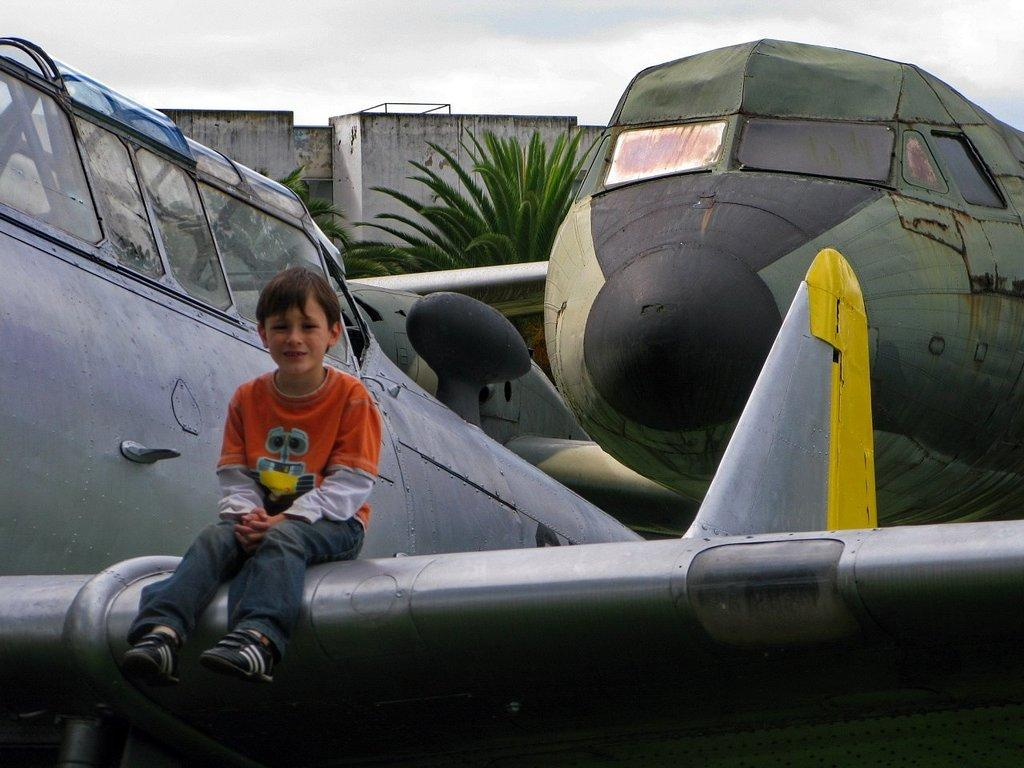What type of objects are featured in the image? There are model aircrafts in the image. What other elements can be seen in the image? There are trees, a sky, a house, and a boy sitting on a model aircraft. Can you describe the setting of the image? The image features a house and trees, with a sky visible in the background. Where is the pan located in the image? There is no pan present in the image. Is the boy wearing a veil while sitting on the model aircraft? There is no indication of a veil or any clothing worn by the boy in the image. 